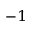<formula> <loc_0><loc_0><loc_500><loc_500>^ { - 1 }</formula> 